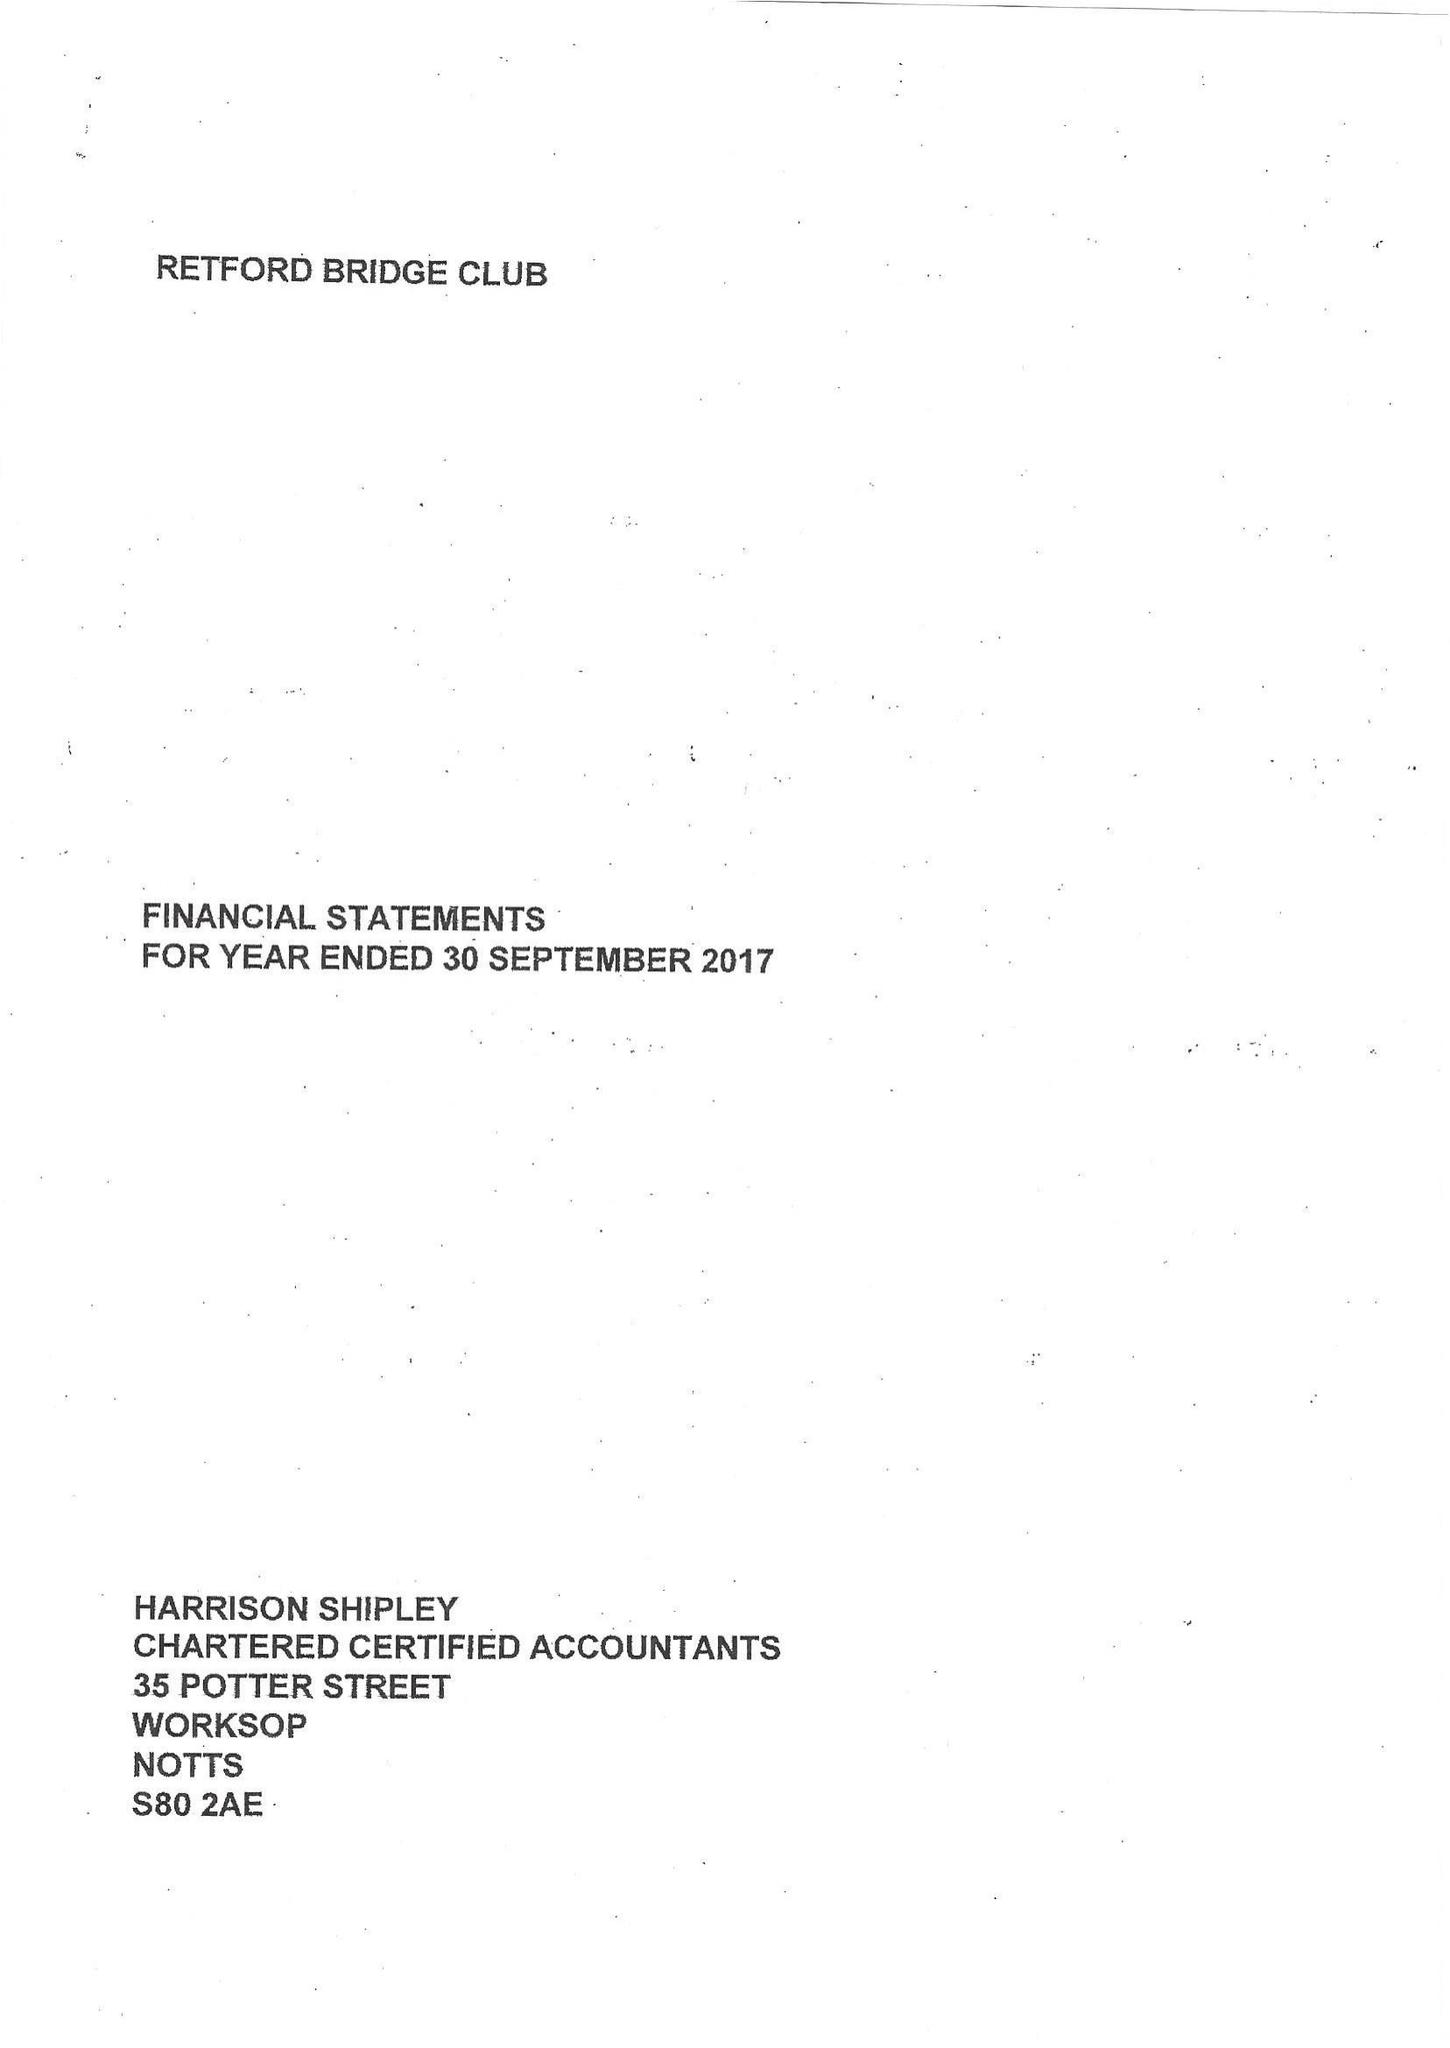What is the value for the address__postcode?
Answer the question using a single word or phrase. S81 8HD 